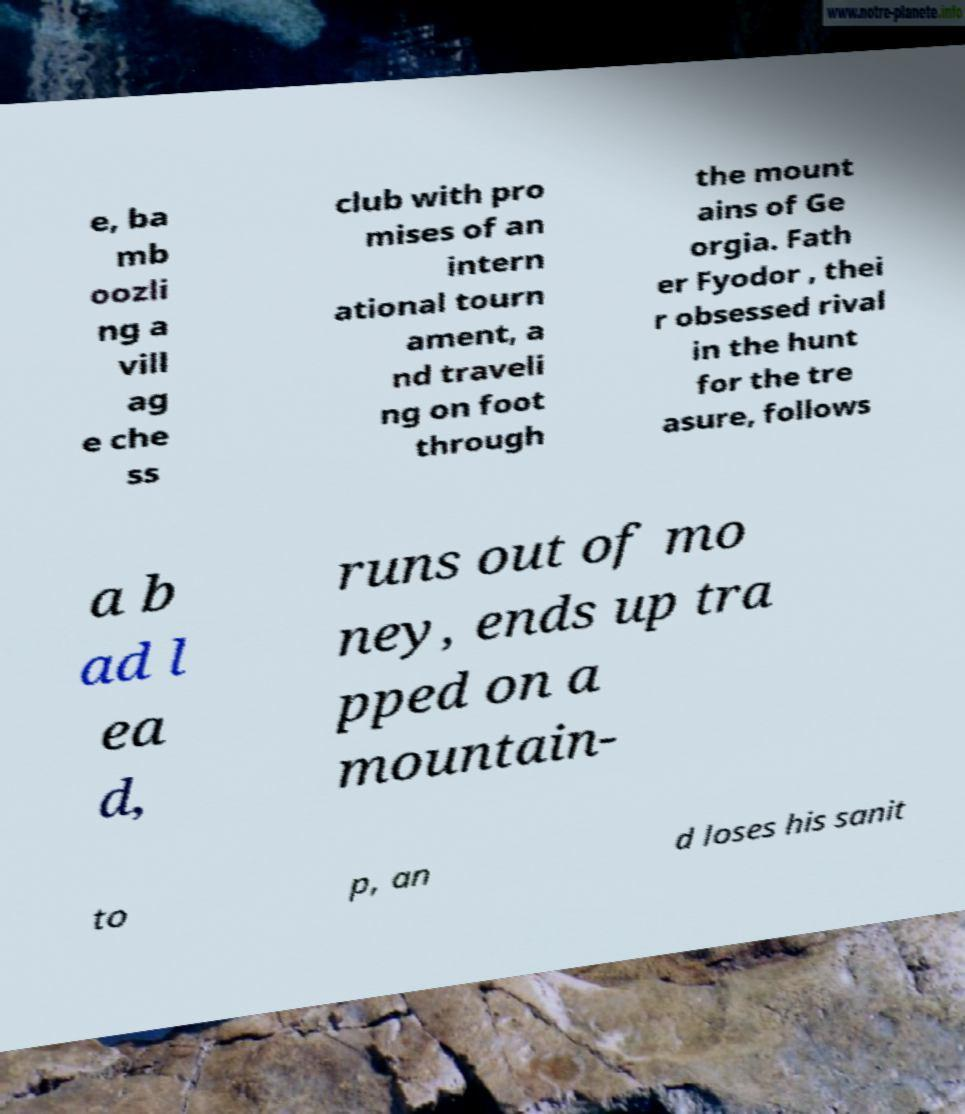There's text embedded in this image that I need extracted. Can you transcribe it verbatim? e, ba mb oozli ng a vill ag e che ss club with pro mises of an intern ational tourn ament, a nd traveli ng on foot through the mount ains of Ge orgia. Fath er Fyodor , thei r obsessed rival in the hunt for the tre asure, follows a b ad l ea d, runs out of mo ney, ends up tra pped on a mountain- to p, an d loses his sanit 